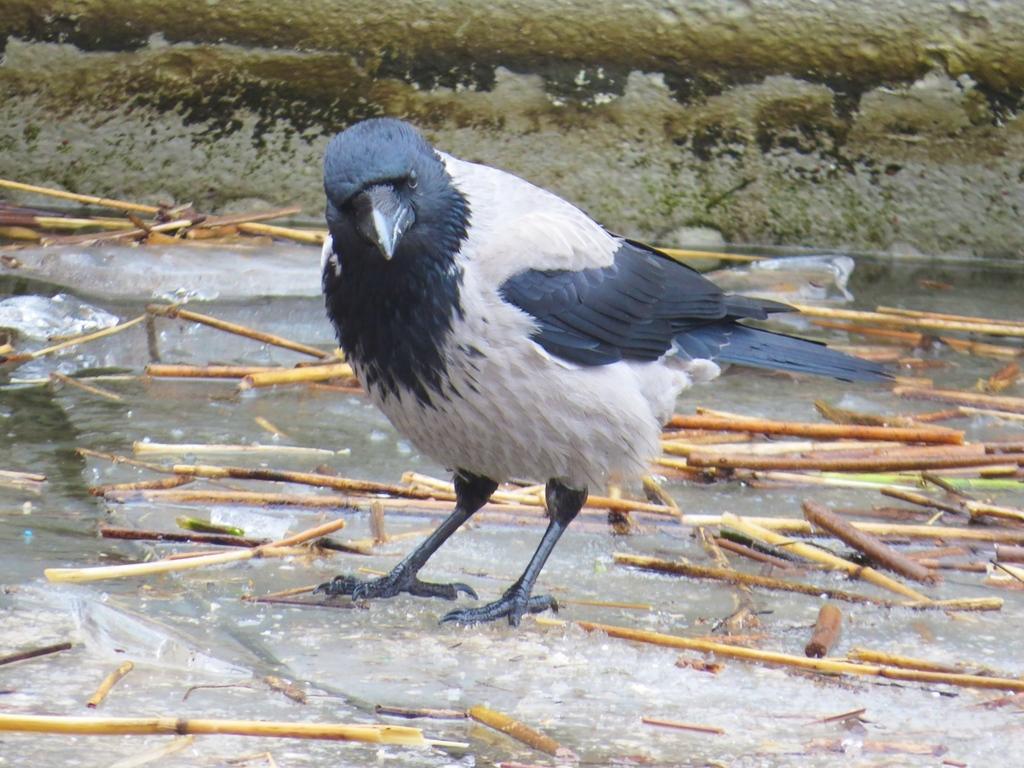How would you summarize this image in a sentence or two? In the image we can see there is a bird standing on the water and there are wooden sticks on the water. 